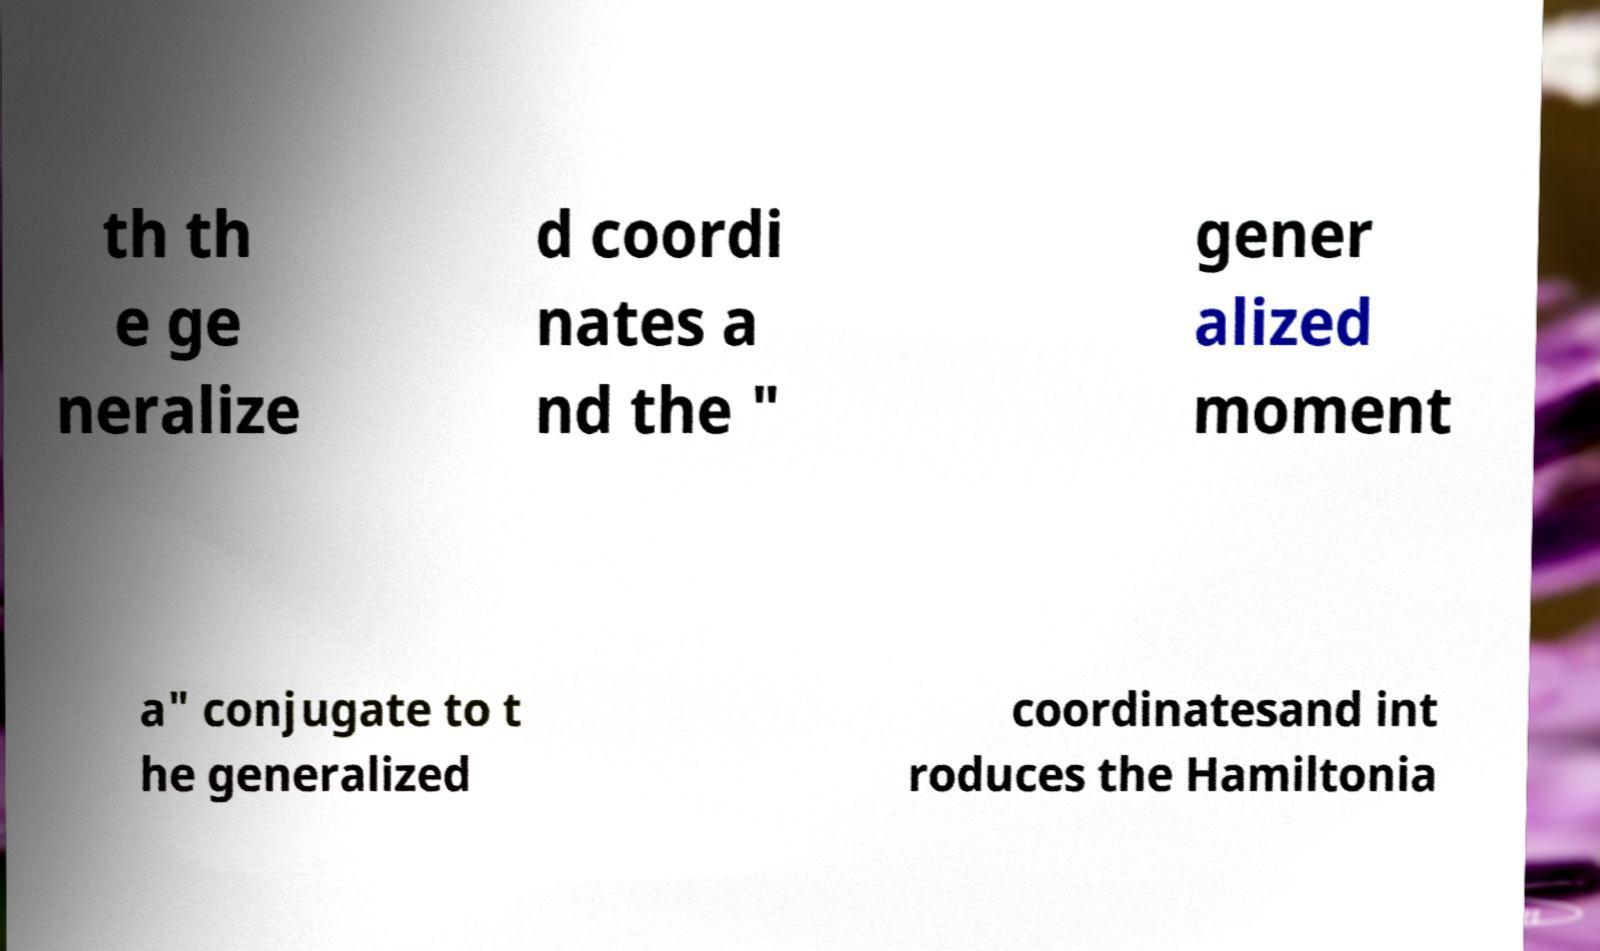Can you read and provide the text displayed in the image?This photo seems to have some interesting text. Can you extract and type it out for me? th th e ge neralize d coordi nates a nd the " gener alized moment a" conjugate to t he generalized coordinatesand int roduces the Hamiltonia 